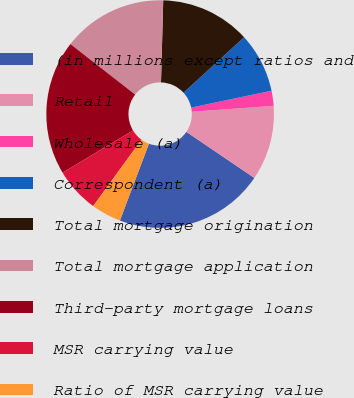Convert chart. <chart><loc_0><loc_0><loc_500><loc_500><pie_chart><fcel>(in millions except ratios and<fcel>Retail<fcel>Wholesale (a)<fcel>Correspondent (a)<fcel>Total mortgage origination<fcel>Total mortgage application<fcel>Third-party mortgage loans<fcel>MSR carrying value<fcel>Ratio of MSR carrying value<nl><fcel>21.27%<fcel>10.64%<fcel>2.13%<fcel>8.51%<fcel>12.77%<fcel>14.89%<fcel>19.15%<fcel>6.38%<fcel>4.26%<nl></chart> 